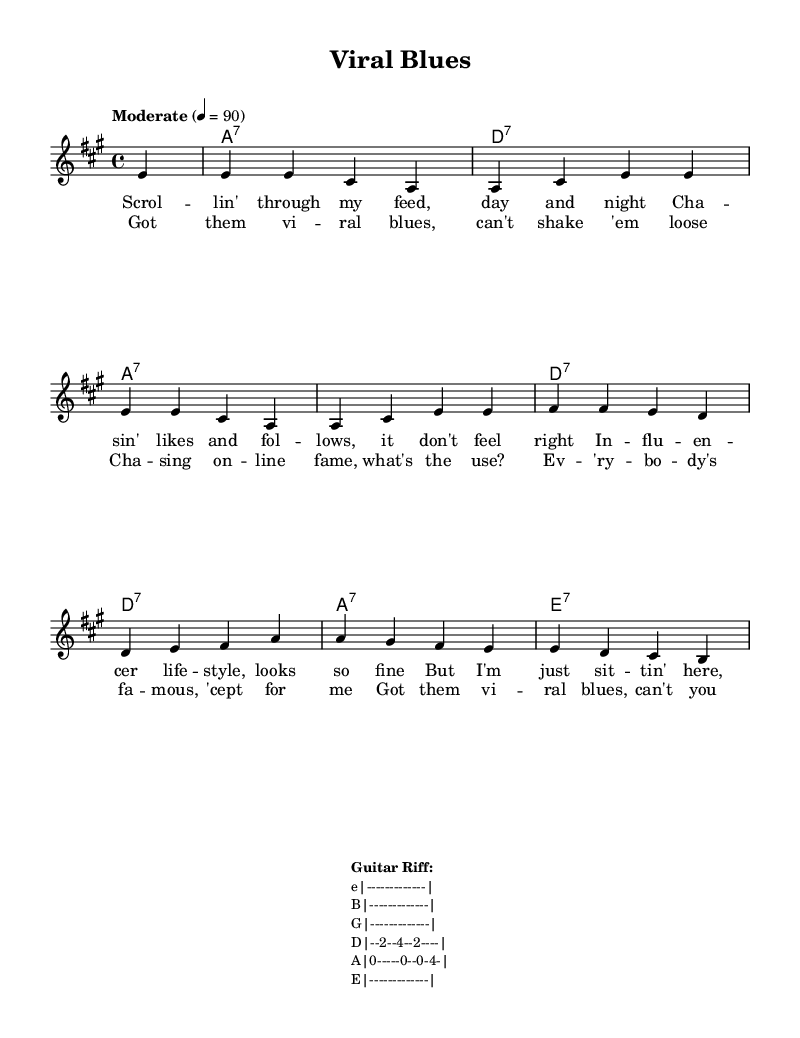What is the key signature of this music? The key signature indicated in the global section is A major, which contains three sharps (F#, C#, and G#).
Answer: A major What is the time signature of this music? The time signature is found in the global section, which shows a four-four time (4/4). This means there are four beats per measure.
Answer: 4/4 What is the tempo marking for this music? The tempo marking is indicated as "Moderate" with a tempo of 90 beats per minute. This sets the pace for the performance of the piece.
Answer: Moderate How many measures are in the melody part? By counting the measures in the melody section, there are a total of eight measures indicated by the individual note groupings and bar lines.
Answer: Eight Which chord is played in the first measure? The first measure indicates an A7 chord, as specified in the harmonies section which shows the chord progression starting with A1:7.
Answer: A7 What is the lyrical theme of the chorus? The chorus discusses the struggles with online fame and the feeling of inadequacy compared to others, reflecting a social commentary on influencers. This is evident in the repeated mention of "viral blues" and questioning the use of chasing fame.
Answer: Viral blues Is the melody mostly ascending or descending? Analyzing the melodic line, it has both ascending and descending patterns, but the initial part tends to ascend, mostly moving from lower notes to higher notes in the first phrase. Overall, there's more upward movement initially, making it primarily ascending.
Answer: Ascending 